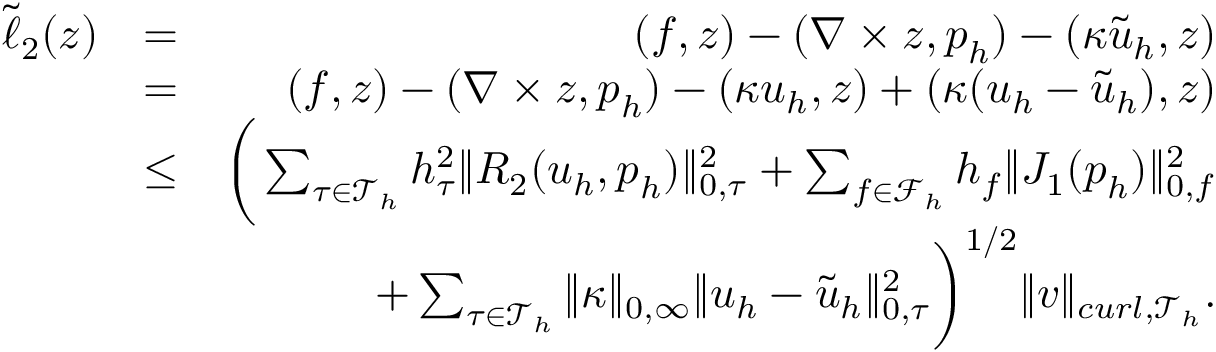<formula> <loc_0><loc_0><loc_500><loc_500>\begin{array} { r l r } { \tilde { \ell } _ { 2 } ( z ) } & { = } & { ( f , z ) - ( \nabla \times z , p _ { h } ) - ( \kappa \tilde { u } _ { h } , z ) } \\ & { = } & { ( f , z ) - ( \nabla \times z , p _ { h } ) - ( \kappa u _ { h } , z ) + ( \kappa ( u _ { h } - \tilde { u } _ { h } ) , z ) } \\ & { \leq } & { \left ( \sum _ { \tau \in \mathcal { T } _ { h } } h _ { \tau } ^ { 2 } \| R _ { 2 } ( u _ { h } , p _ { h } ) \| _ { 0 , \tau } ^ { 2 } + \sum _ { f \in \mathcal { F } _ { h } } h _ { f } \| J _ { 1 } ( p _ { h } ) \| _ { 0 , f } ^ { 2 } \Big . } \\ { \Big . } & { + \sum _ { \tau \in \mathcal { T } _ { h } } \| \kappa \| _ { 0 , \infty } \| u _ { h } - \tilde { u } _ { h } \| _ { 0 , \tau } ^ { 2 } \right ) ^ { 1 / 2 } \| v \| _ { c u r l , \mathcal { T } _ { h } } . } \end{array}</formula> 